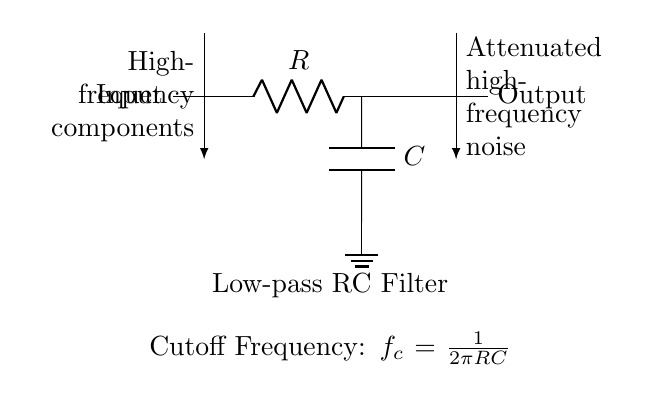What is the component labeled R in the circuit? The component labeled R stands for the resistor, which is used in this low-pass filter circuit to limit current and help define the cutoff frequency along with the capacitor.
Answer: Resistor What is the cutoff frequency for this low-pass filter? The cutoff frequency, denoted as f_c, is calculated using the formula f_c = 1/(2πRC), where R is the resistance and C is the capacitance. From the circuit annotations, this relationship is provided directly.
Answer: f_c = 1/(2πRC) What signals are attenuated in this circuit? The circuit is designed to attenuate high-frequency components of the input signal, allowing only lower frequency signals to pass through to the output. This is indicated by the directional arrow labeled "High-frequency components" at the input.
Answer: High-frequency components What is the function of the capacitor in this circuit? The capacitor in the circuit plays a critical role in filtering; it provides a path to ground for high-frequency signals, effectively reducing their presence in the output. This is a fundamental property of capacitors in RC filter applications.
Answer: Filtering What type of filter is represented in this circuit? The circuit diagram represents a low-pass filter, which specifically allows low-frequency signals to pass while attenuating higher-frequency noise, as indicated in the annotations.
Answer: Low-pass filter How does increasing the resistance value affect the cutoff frequency? Increasing the resistance value R will decrease the cutoff frequency f_c according to the formula f_c = 1/(2πRC). This means that the filter will allow lower frequencies to pass, while attenuating even more of the higher frequencies.
Answer: Decreases cutoff frequency 